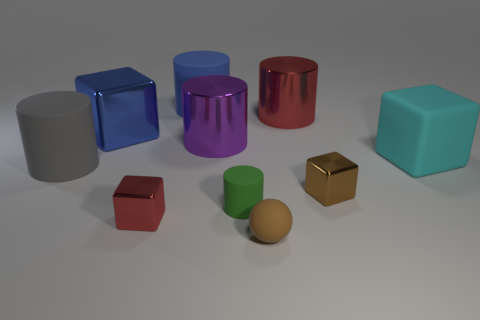There is a thing behind the red cylinder; is its size the same as the small sphere?
Provide a short and direct response. No. There is a brown rubber ball in front of the big gray thing; what size is it?
Provide a succinct answer. Small. There is a green thing that is the same shape as the big red shiny thing; what is its size?
Your answer should be compact. Small. What size is the metal block that is right of the large matte cylinder that is behind the big metallic block?
Provide a succinct answer. Small. There is a red metallic thing behind the gray object left of the metallic block that is behind the cyan thing; what is its shape?
Give a very brief answer. Cylinder. What size is the blue matte object?
Your answer should be very brief. Large. What is the color of the big block that is the same material as the small green object?
Provide a succinct answer. Cyan. How many large cylinders are the same material as the large purple object?
Make the answer very short. 1. There is a rubber ball; is its color the same as the small metal object that is right of the purple metal cylinder?
Make the answer very short. Yes. The large matte object right of the green matte cylinder on the left side of the large cyan rubber thing is what color?
Give a very brief answer. Cyan. 